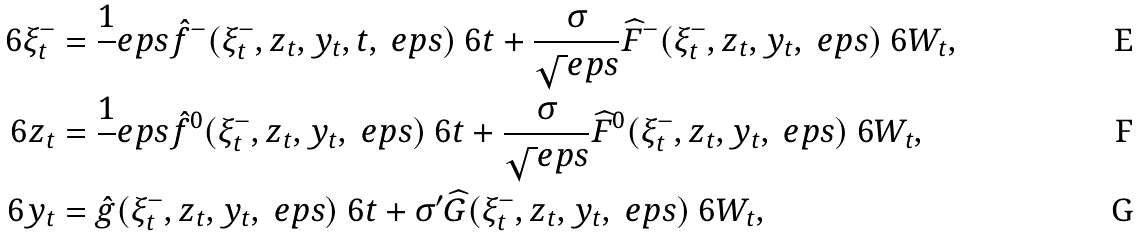<formula> <loc_0><loc_0><loc_500><loc_500>\ 6 \xi ^ { - } _ { t } & = \frac { 1 } { \ } e p s \hat { f } ^ { - } ( \xi ^ { - } _ { t } , z _ { t } , y _ { t } , t , \ e p s ) \ 6 t + \frac { \sigma } { \sqrt { \ } e p s } \widehat { F } ^ { - } ( \xi ^ { - } _ { t } , z _ { t } , y _ { t } , \ e p s ) \ 6 W _ { t } , \\ \ 6 z _ { t } & = \frac { 1 } { \ } e p s \hat { f } ^ { 0 } ( \xi ^ { - } _ { t } , z _ { t } , y _ { t } , \ e p s ) \ 6 t + \frac { \sigma } { \sqrt { \ } e p s } \widehat { F } ^ { 0 } ( \xi ^ { - } _ { t } , z _ { t } , y _ { t } , \ e p s ) \ 6 W _ { t } , \\ \ 6 y _ { t } & = \hat { g } ( \xi ^ { - } _ { t } , z _ { t } , y _ { t } , \ e p s ) \ 6 t + \sigma ^ { \prime } \widehat { G } ( \xi ^ { - } _ { t } , z _ { t } , y _ { t } , \ e p s ) \ 6 W _ { t } ,</formula> 